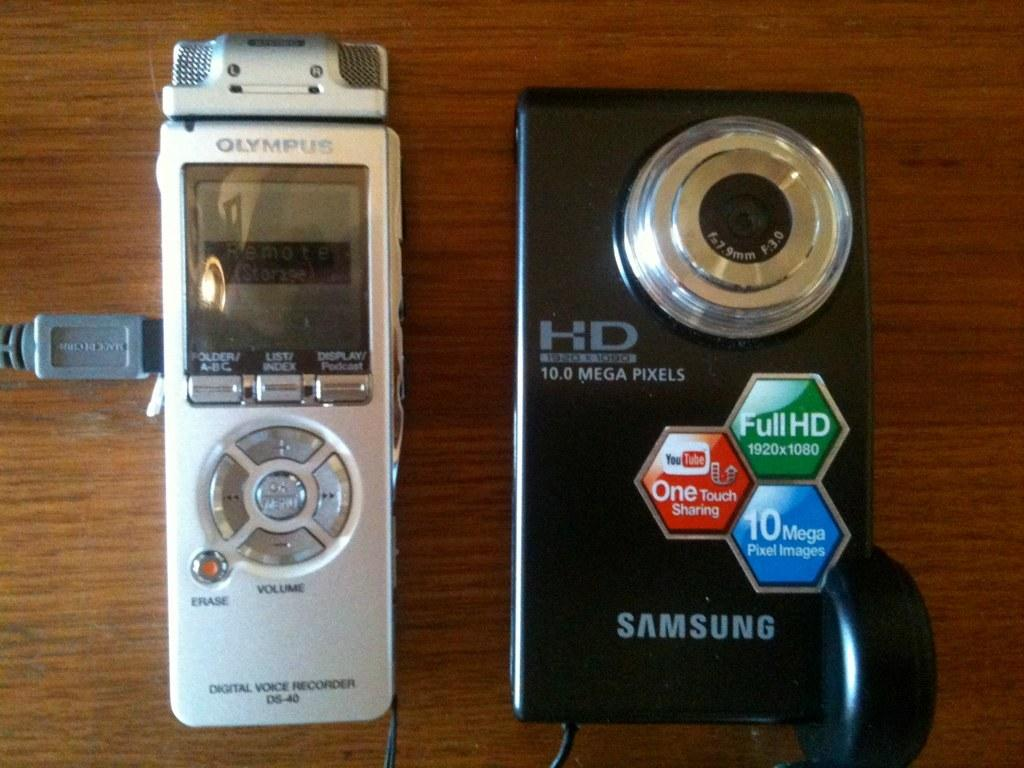<image>
Write a terse but informative summary of the picture. A black HD Samsung camera is next to a silver Olympus device. 